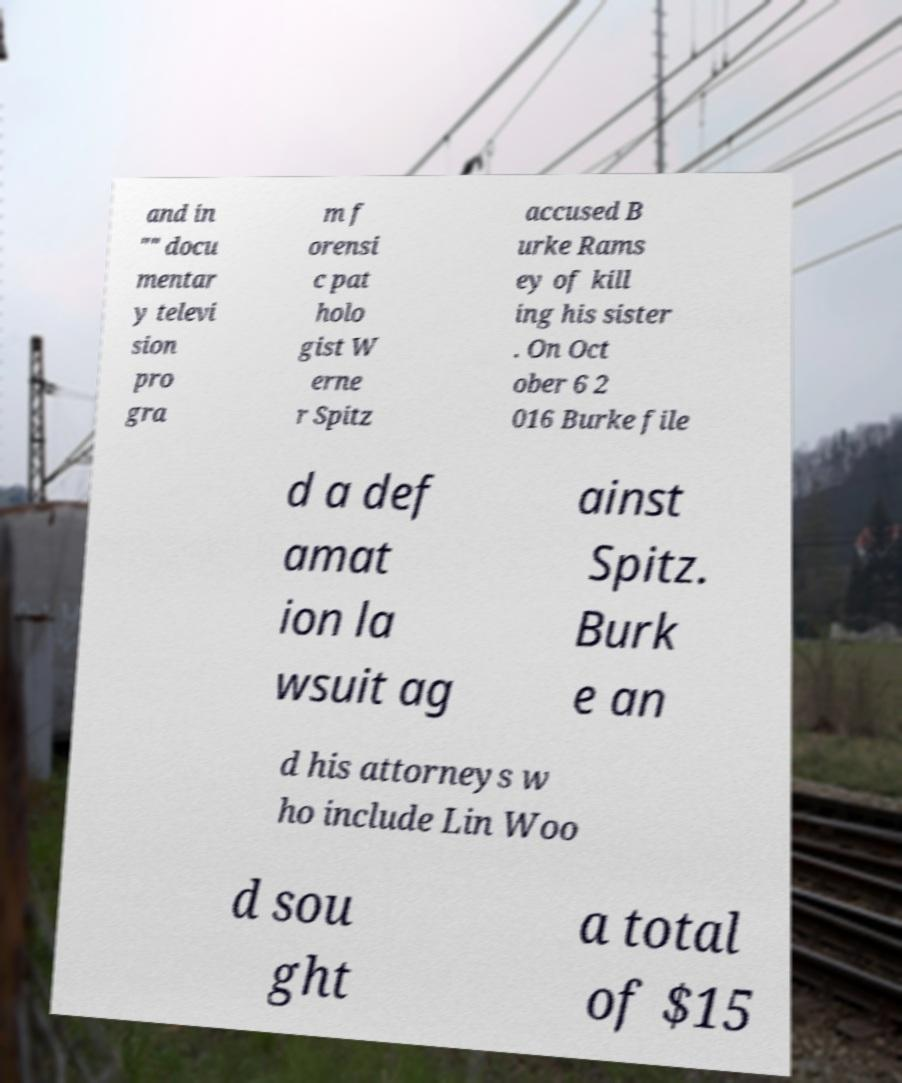Can you read and provide the text displayed in the image?This photo seems to have some interesting text. Can you extract and type it out for me? and in "" docu mentar y televi sion pro gra m f orensi c pat holo gist W erne r Spitz accused B urke Rams ey of kill ing his sister . On Oct ober 6 2 016 Burke file d a def amat ion la wsuit ag ainst Spitz. Burk e an d his attorneys w ho include Lin Woo d sou ght a total of $15 